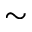<formula> <loc_0><loc_0><loc_500><loc_500>\sim</formula> 